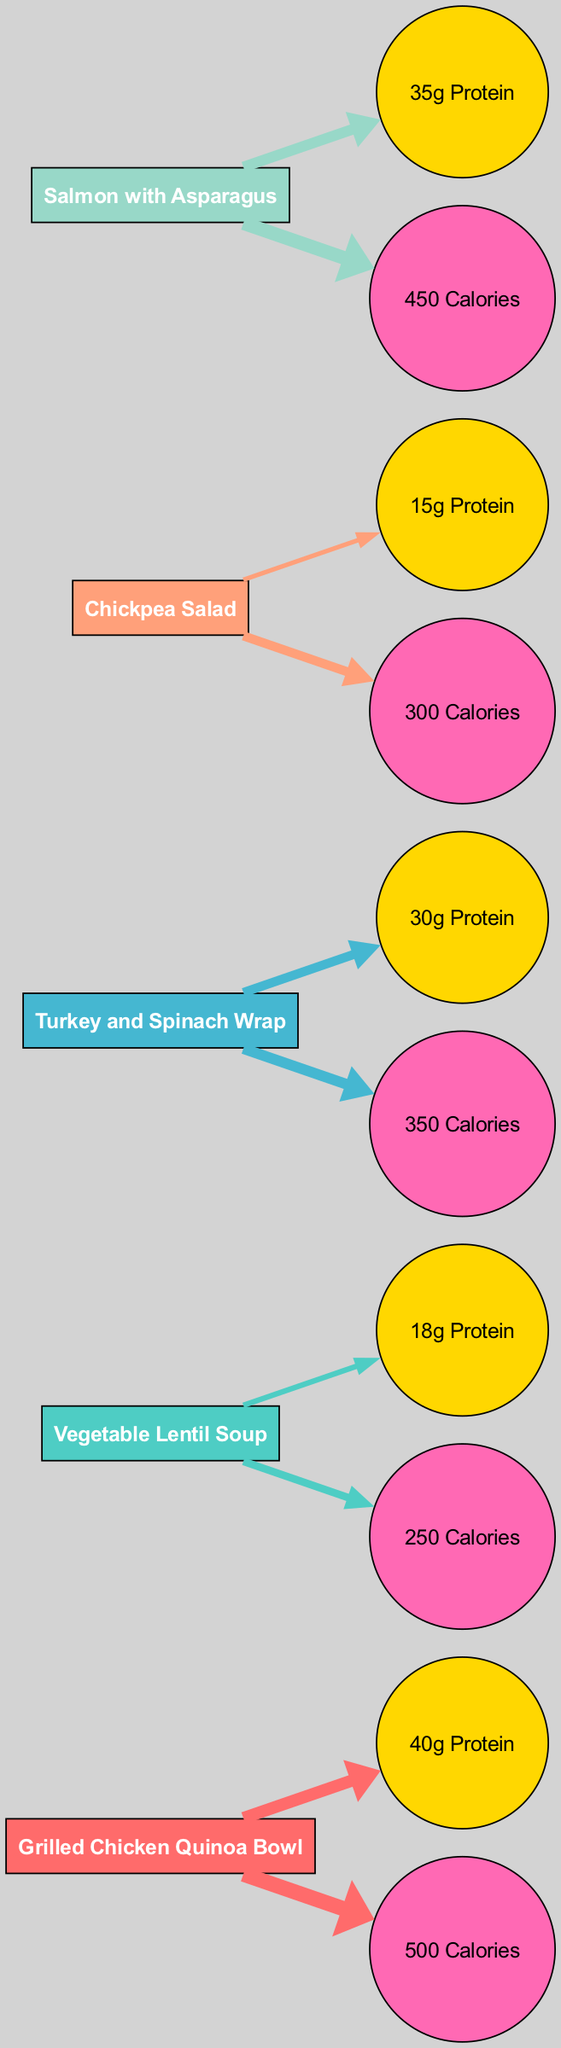What is the protein content of the Grilled Chicken Quinoa Bowl? The diagram shows a specific node for the Grilled Chicken Quinoa Bowl, which indicates it contains 40 grams of protein.
Answer: 40 grams How many calories does the Vegetable Lentil Soup have? By examining the Vegetable Lentil Soup node in the diagram, we can see that it specifies 250 calories.
Answer: 250 calories Which meal has the highest protein content? The nodes can be compared based on the provided protein values. The Grilled Chicken Quinoa Bowl has the highest protein content at 40 grams.
Answer: Grilled Chicken Quinoa Bowl What is the total protein content of the Turkey and Spinach Wrap? The Turkey and Spinach Wrap node indicates 30 grams of protein, which directly answers the question.
Answer: 30 grams How many nodes are present in the diagram? The diagram consists of 5 meal nodes, each connected to a protein node and a calories node, totaling 15 nodes.
Answer: 15 nodes Which meal has the lowest calorie count? Comparing the calorie nodes in the diagram shows that the Vegetable Lentil Soup has the lowest at 250 calories.
Answer: Vegetable Lentil Soup What is the total protein content of all meals combined? Adding the protein contents from all meal nodes: 40 + 18 + 30 + 15 + 35 = 138 grams of protein.
Answer: 138 grams Which meal has the same calorie count as the protein content of the Chickpea Salad? The Chickpea Salad has 15 grams of protein, but it has 300 calories, making the comparison relevant. The question effectively inquires about other meals with similar values, but there are no overlaps mentioned here.
Answer: None Which meal has the highest calorie count? By examining the calorie nodes, the Grilled Chicken Quinoa Bowl has the highest calorie count at 500 calories compared to the others.
Answer: Grilled Chicken Quinoa Bowl What color represents the Salmon with Asparagus in the diagram? Each meal node has a unique color defined in the diagram; the Salmon with Asparagus is depicted in the same color as its associated edges, which is a specific shade from the defined color palette.
Answer: Specific color (e.g., #FF6B6B) 